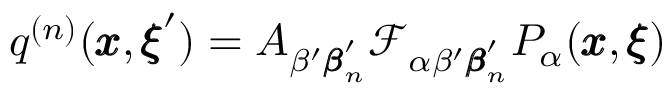Convert formula to latex. <formula><loc_0><loc_0><loc_500><loc_500>q ^ { ( n ) } ( { \pm b x } , { \pm b \xi } ^ { \prime } ) = A _ { \beta ^ { \prime } { \pm b \beta } _ { n } ^ { \prime } } { \mathcal { F } _ { \alpha \beta ^ { \prime } { \pm b \beta } _ { n } ^ { \prime } } P _ { \alpha } ( { \pm b x } , { \pm b \xi } ) }</formula> 